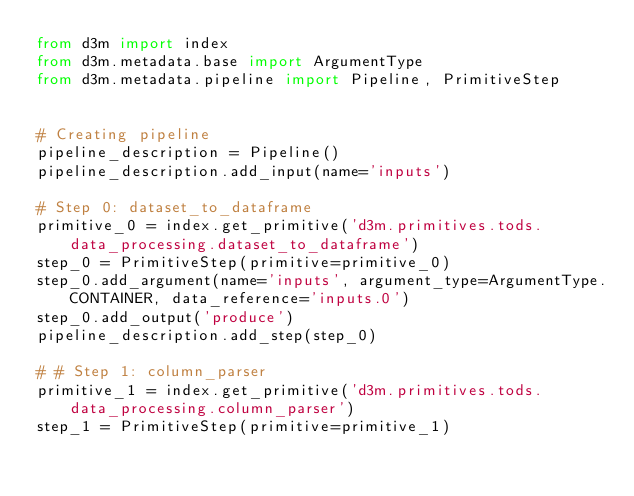Convert code to text. <code><loc_0><loc_0><loc_500><loc_500><_Python_>from d3m import index
from d3m.metadata.base import ArgumentType
from d3m.metadata.pipeline import Pipeline, PrimitiveStep


# Creating pipeline
pipeline_description = Pipeline()
pipeline_description.add_input(name='inputs')

# Step 0: dataset_to_dataframe
primitive_0 = index.get_primitive('d3m.primitives.tods.data_processing.dataset_to_dataframe')
step_0 = PrimitiveStep(primitive=primitive_0)
step_0.add_argument(name='inputs', argument_type=ArgumentType.CONTAINER, data_reference='inputs.0')
step_0.add_output('produce')
pipeline_description.add_step(step_0)

# # Step 1: column_parser
primitive_1 = index.get_primitive('d3m.primitives.tods.data_processing.column_parser')
step_1 = PrimitiveStep(primitive=primitive_1)</code> 